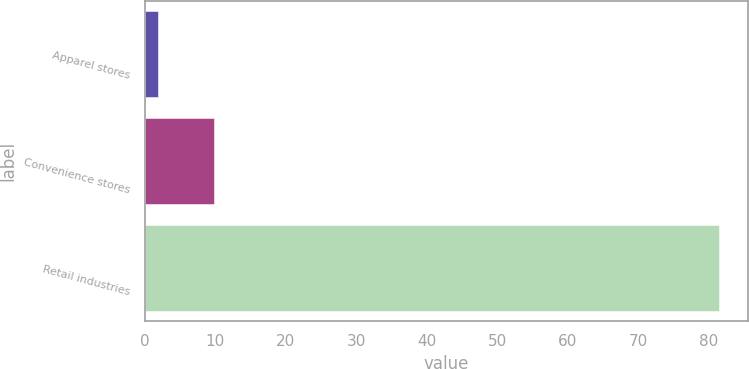<chart> <loc_0><loc_0><loc_500><loc_500><bar_chart><fcel>Apparel stores<fcel>Convenience stores<fcel>Retail industries<nl><fcel>1.9<fcel>9.86<fcel>81.5<nl></chart> 